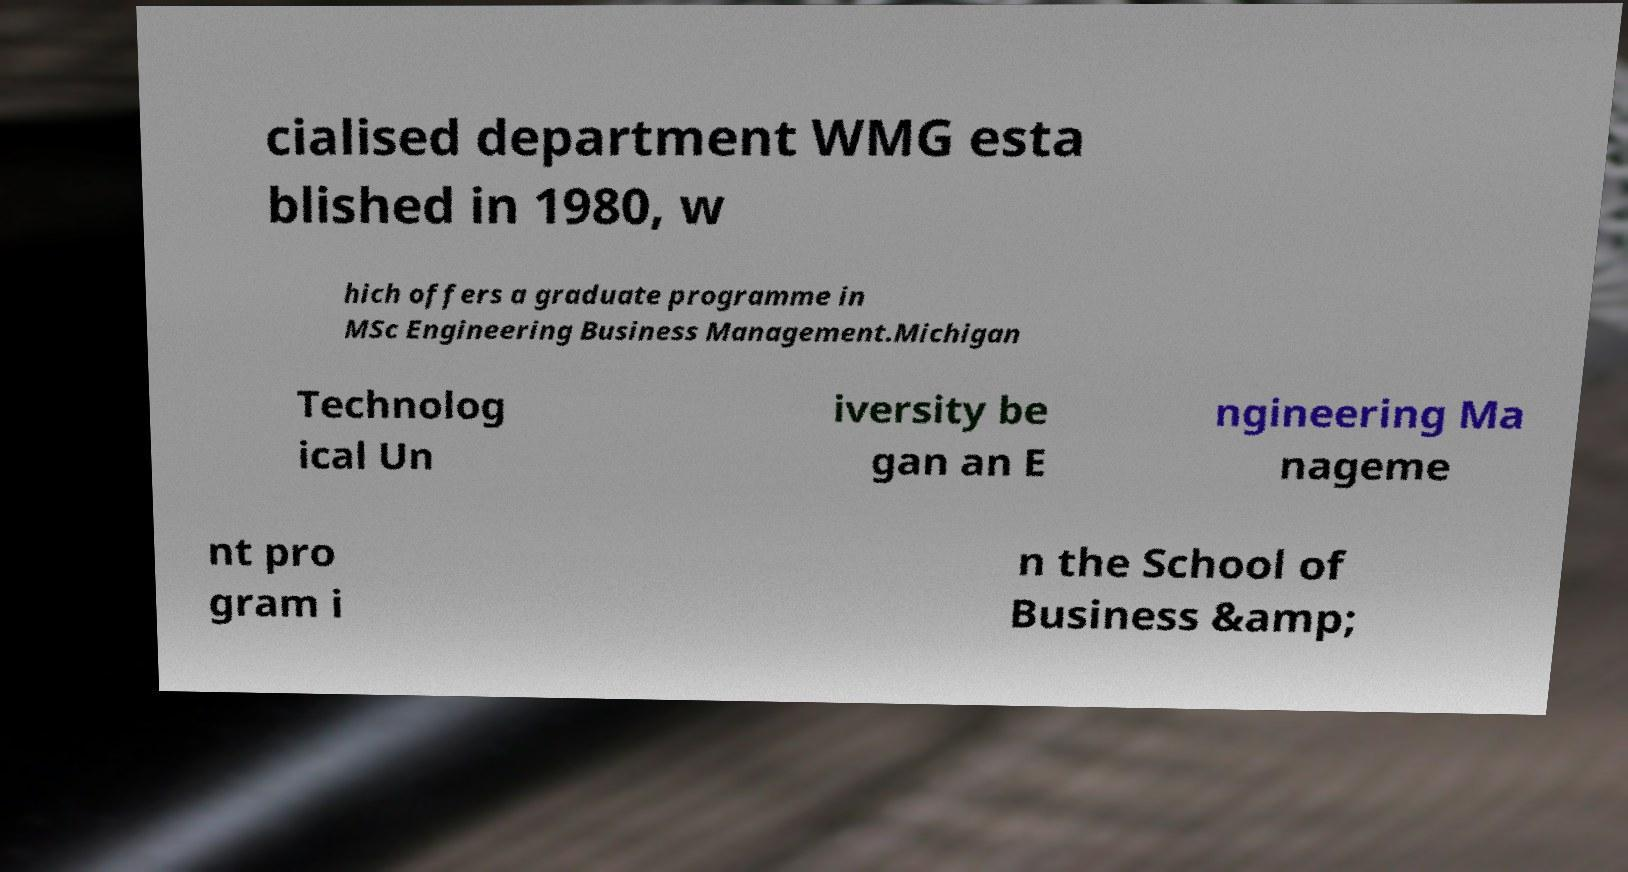Could you assist in decoding the text presented in this image and type it out clearly? cialised department WMG esta blished in 1980, w hich offers a graduate programme in MSc Engineering Business Management.Michigan Technolog ical Un iversity be gan an E ngineering Ma nageme nt pro gram i n the School of Business &amp; 